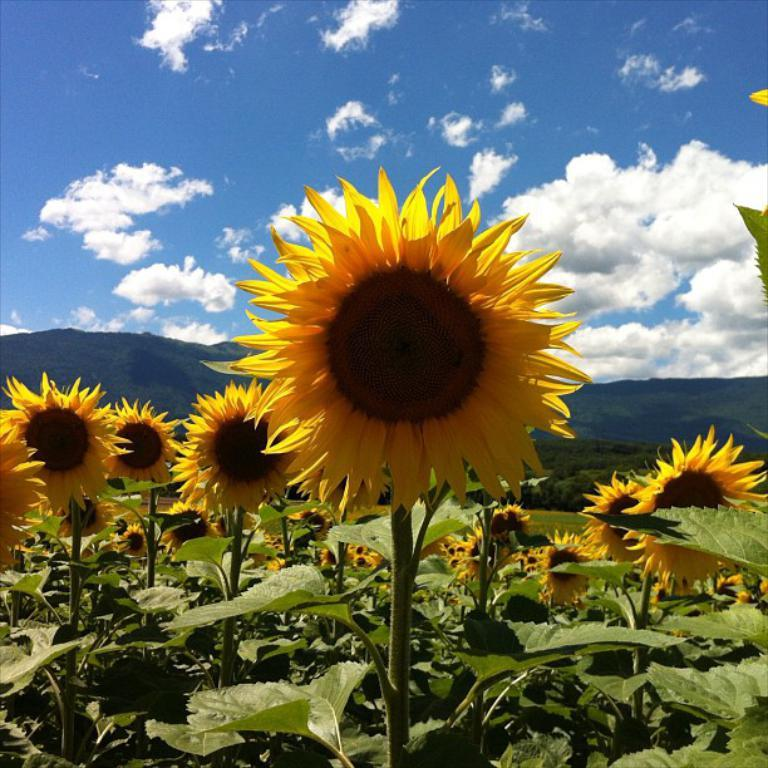What type of vegetation can be seen in the image? There are flowers and plants in the image. What type of landscape is visible in the image? Hills are visible in the image. What is the condition of the sky in the image? The sky is cloudy in the image. How many potatoes are visible in the image? There are no potatoes present in the image. What type of leaf is featured on the plants in the image? The provided facts do not mention any specific type of leaf on the plants in the image. 